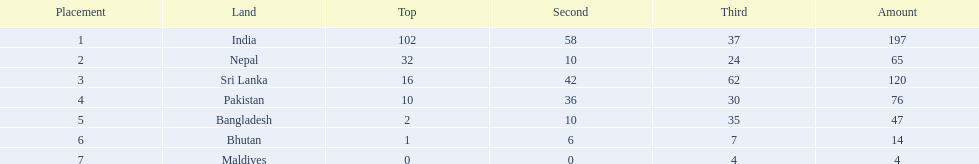What were the total amount won of medals by nations in the 1999 south asian games? 197, 65, 120, 76, 47, 14, 4. Which amount was the lowest? 4. Which nation had this amount? Maldives. 